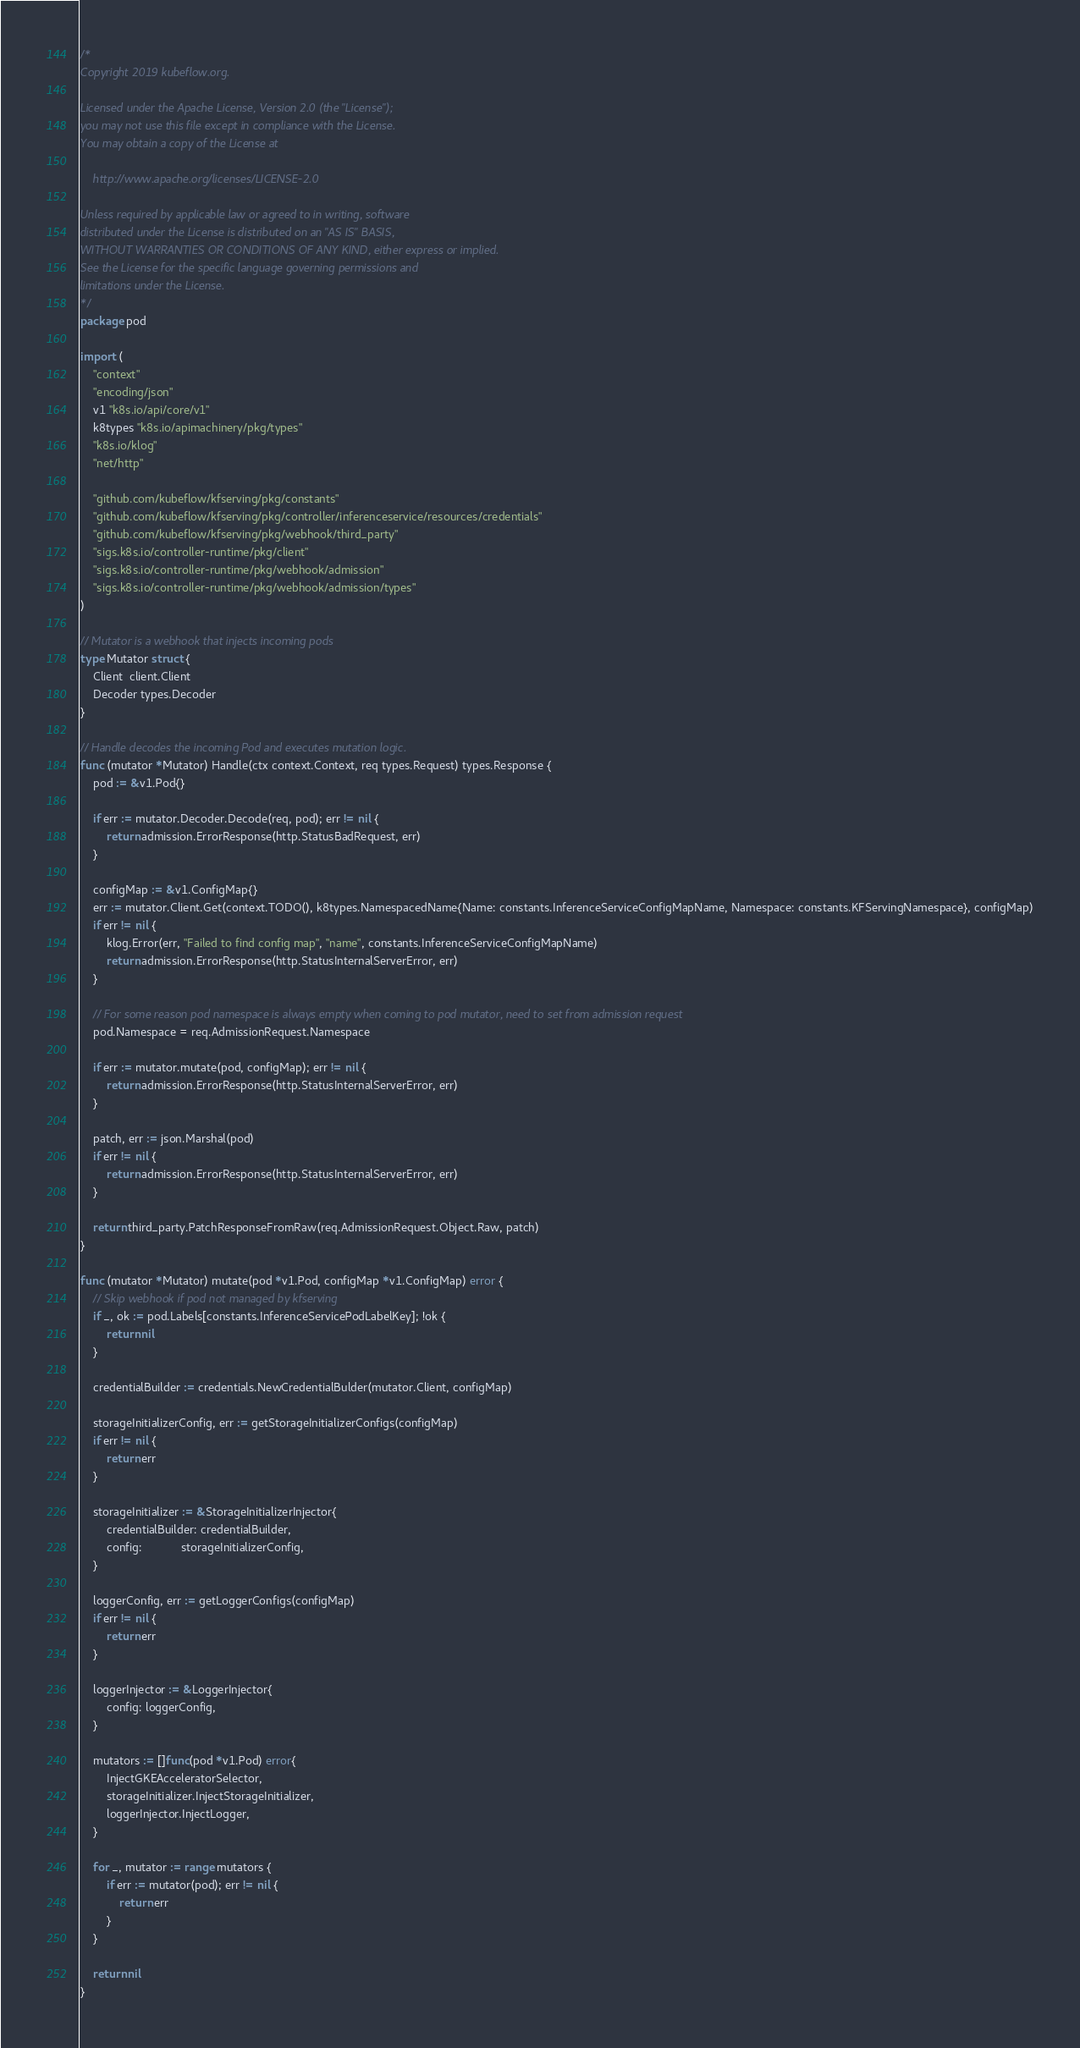Convert code to text. <code><loc_0><loc_0><loc_500><loc_500><_Go_>/*
Copyright 2019 kubeflow.org.

Licensed under the Apache License, Version 2.0 (the "License");
you may not use this file except in compliance with the License.
You may obtain a copy of the License at

    http://www.apache.org/licenses/LICENSE-2.0

Unless required by applicable law or agreed to in writing, software
distributed under the License is distributed on an "AS IS" BASIS,
WITHOUT WARRANTIES OR CONDITIONS OF ANY KIND, either express or implied.
See the License for the specific language governing permissions and
limitations under the License.
*/
package pod

import (
	"context"
	"encoding/json"
	v1 "k8s.io/api/core/v1"
	k8types "k8s.io/apimachinery/pkg/types"
	"k8s.io/klog"
	"net/http"

	"github.com/kubeflow/kfserving/pkg/constants"
	"github.com/kubeflow/kfserving/pkg/controller/inferenceservice/resources/credentials"
	"github.com/kubeflow/kfserving/pkg/webhook/third_party"
	"sigs.k8s.io/controller-runtime/pkg/client"
	"sigs.k8s.io/controller-runtime/pkg/webhook/admission"
	"sigs.k8s.io/controller-runtime/pkg/webhook/admission/types"
)

// Mutator is a webhook that injects incoming pods
type Mutator struct {
	Client  client.Client
	Decoder types.Decoder
}

// Handle decodes the incoming Pod and executes mutation logic.
func (mutator *Mutator) Handle(ctx context.Context, req types.Request) types.Response {
	pod := &v1.Pod{}

	if err := mutator.Decoder.Decode(req, pod); err != nil {
		return admission.ErrorResponse(http.StatusBadRequest, err)
	}

	configMap := &v1.ConfigMap{}
	err := mutator.Client.Get(context.TODO(), k8types.NamespacedName{Name: constants.InferenceServiceConfigMapName, Namespace: constants.KFServingNamespace}, configMap)
	if err != nil {
		klog.Error(err, "Failed to find config map", "name", constants.InferenceServiceConfigMapName)
		return admission.ErrorResponse(http.StatusInternalServerError, err)
	}

	// For some reason pod namespace is always empty when coming to pod mutator, need to set from admission request
	pod.Namespace = req.AdmissionRequest.Namespace

	if err := mutator.mutate(pod, configMap); err != nil {
		return admission.ErrorResponse(http.StatusInternalServerError, err)
	}

	patch, err := json.Marshal(pod)
	if err != nil {
		return admission.ErrorResponse(http.StatusInternalServerError, err)
	}

	return third_party.PatchResponseFromRaw(req.AdmissionRequest.Object.Raw, patch)
}

func (mutator *Mutator) mutate(pod *v1.Pod, configMap *v1.ConfigMap) error {
	// Skip webhook if pod not managed by kfserving
	if _, ok := pod.Labels[constants.InferenceServicePodLabelKey]; !ok {
		return nil
	}

	credentialBuilder := credentials.NewCredentialBulder(mutator.Client, configMap)

	storageInitializerConfig, err := getStorageInitializerConfigs(configMap)
	if err != nil {
		return err
	}

	storageInitializer := &StorageInitializerInjector{
		credentialBuilder: credentialBuilder,
		config:            storageInitializerConfig,
	}

	loggerConfig, err := getLoggerConfigs(configMap)
	if err != nil {
		return err
	}

	loggerInjector := &LoggerInjector{
		config: loggerConfig,
	}

	mutators := []func(pod *v1.Pod) error{
		InjectGKEAcceleratorSelector,
		storageInitializer.InjectStorageInitializer,
		loggerInjector.InjectLogger,
	}

	for _, mutator := range mutators {
		if err := mutator(pod); err != nil {
			return err
		}
	}

	return nil
}
</code> 